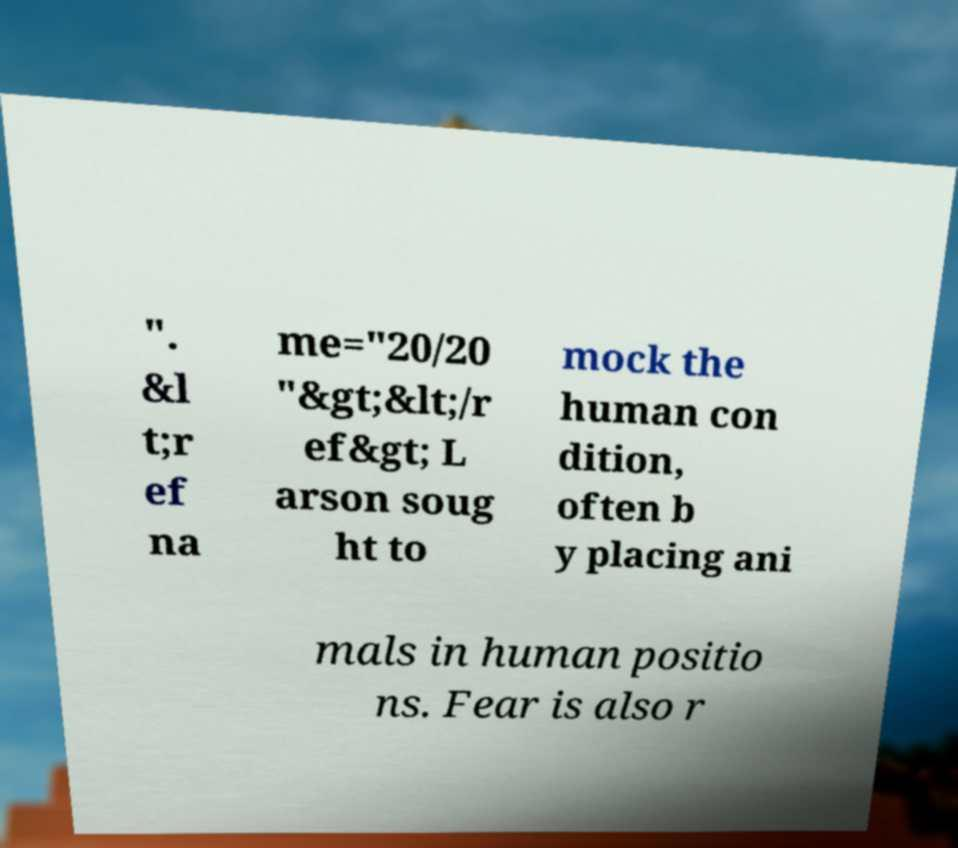Please identify and transcribe the text found in this image. ". &l t;r ef na me="20/20 "&gt;&lt;/r ef&gt; L arson soug ht to mock the human con dition, often b y placing ani mals in human positio ns. Fear is also r 